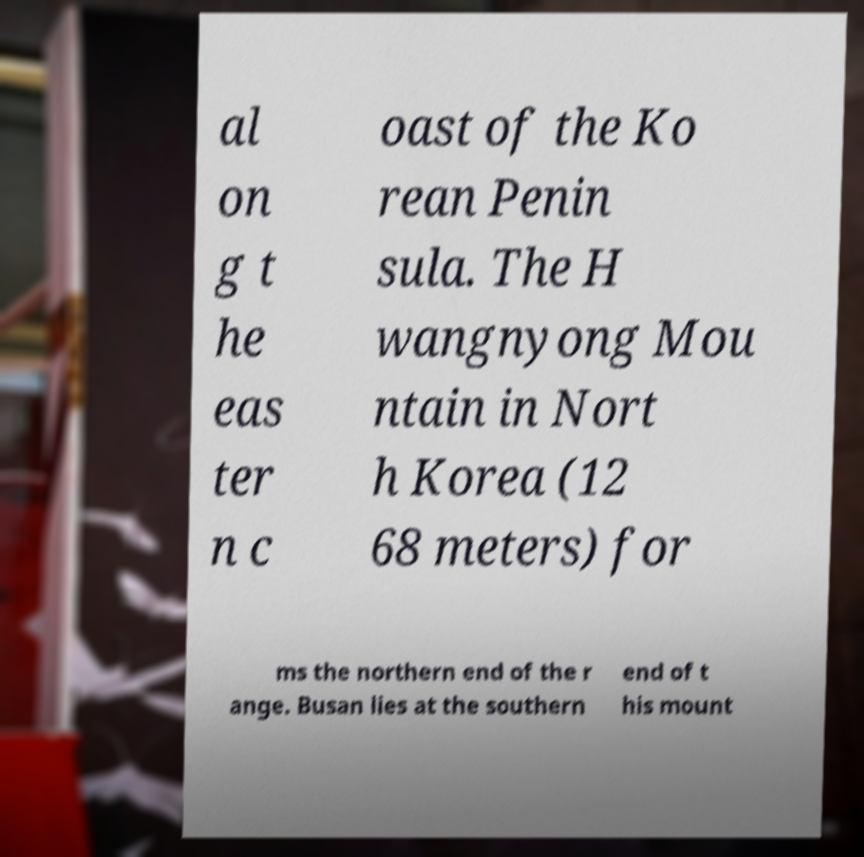I need the written content from this picture converted into text. Can you do that? al on g t he eas ter n c oast of the Ko rean Penin sula. The H wangnyong Mou ntain in Nort h Korea (12 68 meters) for ms the northern end of the r ange. Busan lies at the southern end of t his mount 